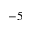Convert formula to latex. <formula><loc_0><loc_0><loc_500><loc_500>- 5</formula> 